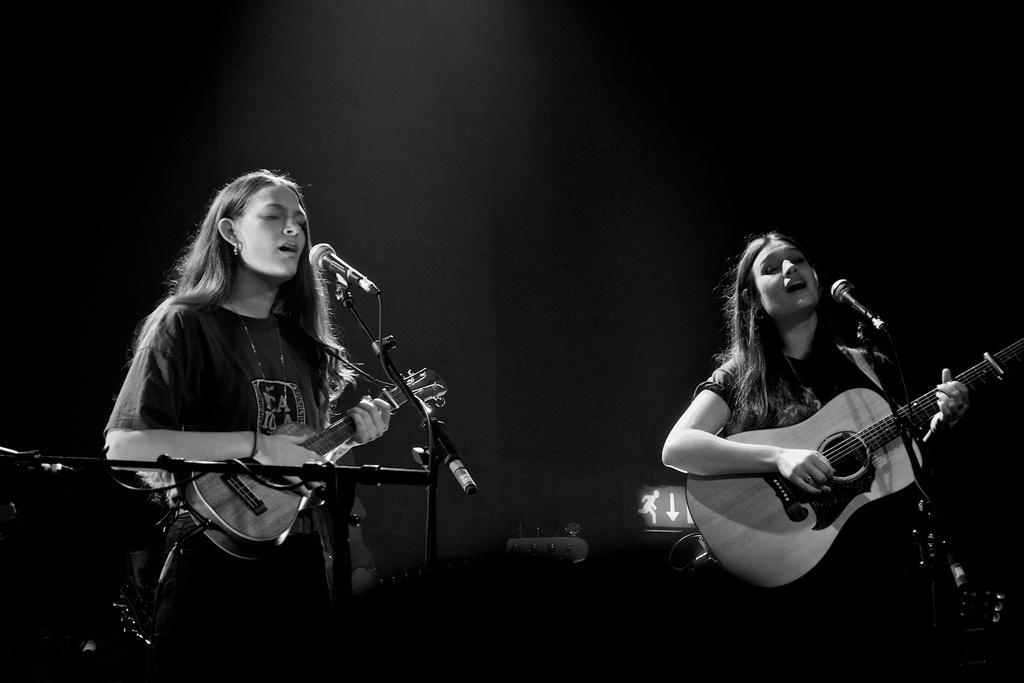Could you give a brief overview of what you see in this image? Girls are playing guitar,this is microphone. 